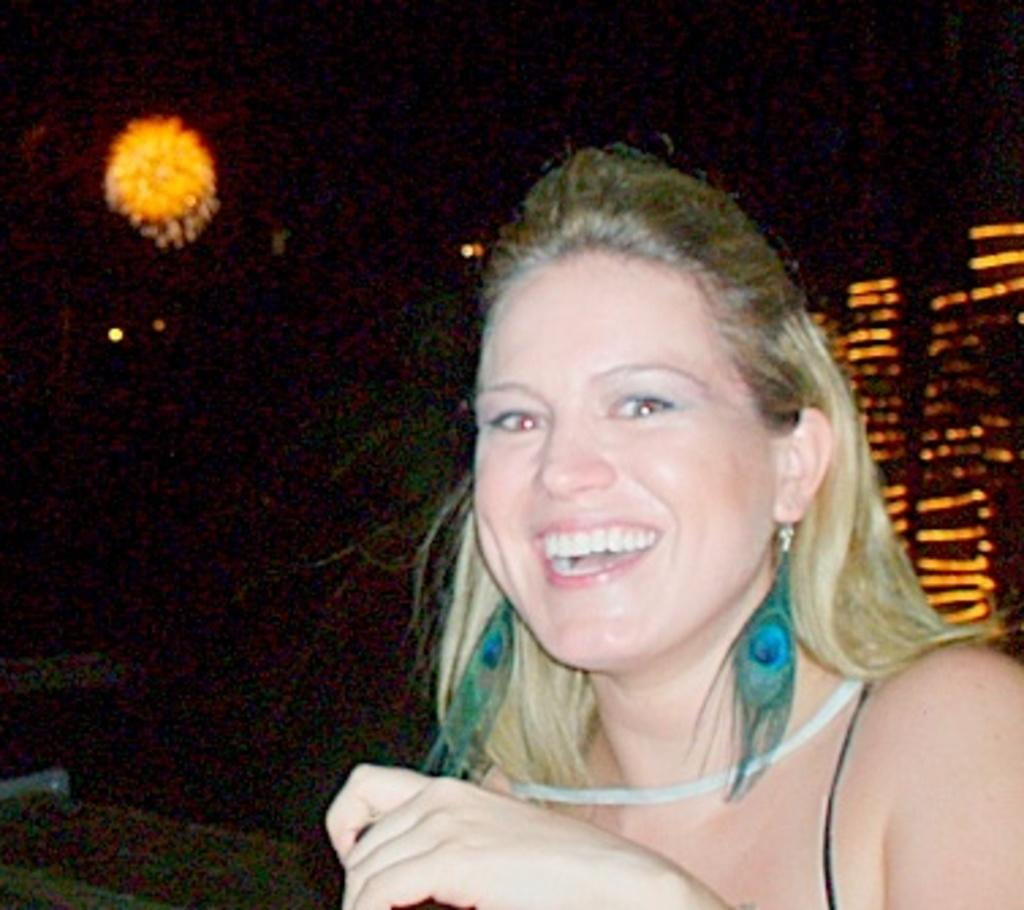Who is present in the image? There is a woman in the image. Where is the woman located in the image? The woman is on the right side of the image. What can be seen in the background of the image? There are lights in the background of the image. What type of pan is the woman using to solve the riddle in the image? There is no pan or riddle present in the image; it features a woman on the right side with lights in the background. 